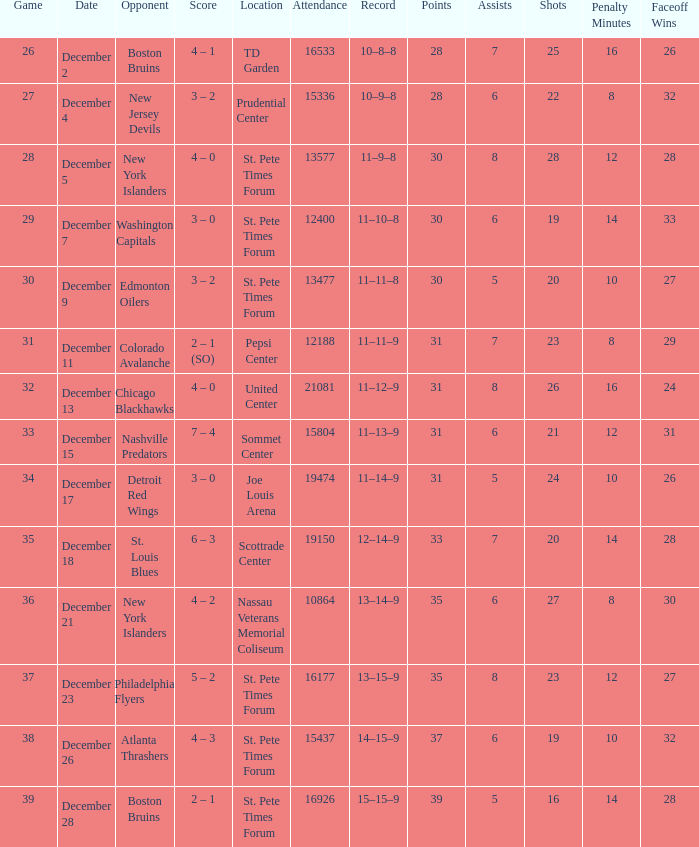What was the largest attended game? 21081.0. 